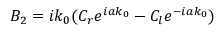Convert formula to latex. <formula><loc_0><loc_0><loc_500><loc_500>B _ { 2 } = i k _ { 0 } ( C _ { r } e ^ { i a k _ { 0 } } - C _ { l } e ^ { - i a k _ { 0 } } )</formula> 